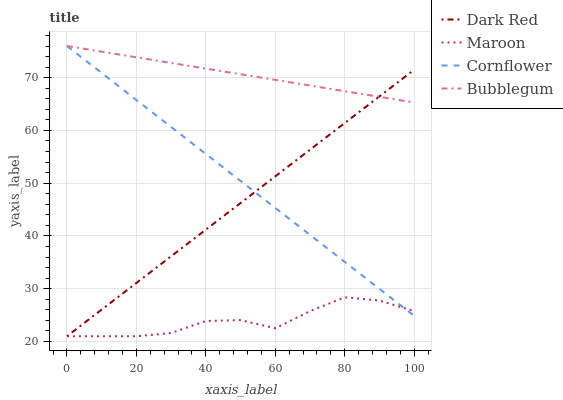Does Bubblegum have the minimum area under the curve?
Answer yes or no. No. Does Maroon have the maximum area under the curve?
Answer yes or no. No. Is Bubblegum the smoothest?
Answer yes or no. No. Is Bubblegum the roughest?
Answer yes or no. No. Does Bubblegum have the lowest value?
Answer yes or no. No. Does Maroon have the highest value?
Answer yes or no. No. Is Maroon less than Bubblegum?
Answer yes or no. Yes. Is Bubblegum greater than Maroon?
Answer yes or no. Yes. Does Maroon intersect Bubblegum?
Answer yes or no. No. 